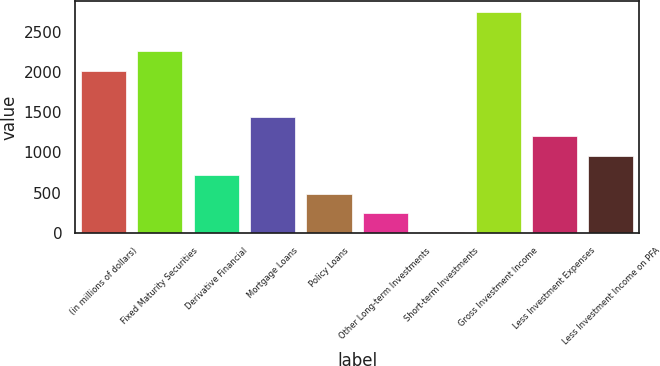<chart> <loc_0><loc_0><loc_500><loc_500><bar_chart><fcel>(in millions of dollars)<fcel>Fixed Maturity Securities<fcel>Derivative Financial<fcel>Mortgage Loans<fcel>Policy Loans<fcel>Other Long-term Investments<fcel>Short-term Investments<fcel>Gross Investment Income<fcel>Less Investment Expenses<fcel>Less Investment Income on PFA<nl><fcel>2009<fcel>2268.5<fcel>722.97<fcel>1439.04<fcel>484.28<fcel>245.59<fcel>6.9<fcel>2745.88<fcel>1200.35<fcel>961.66<nl></chart> 